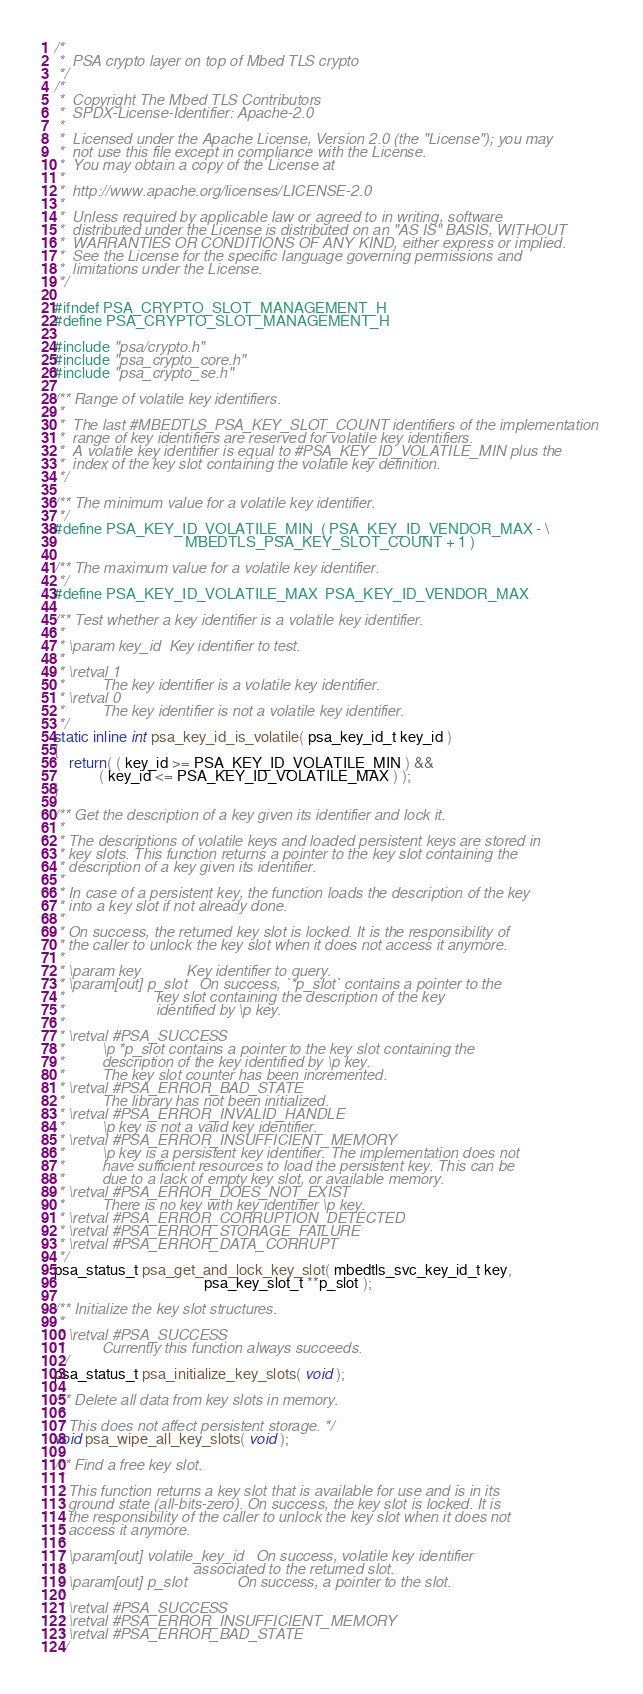Convert code to text. <code><loc_0><loc_0><loc_500><loc_500><_C_>/*
 *  PSA crypto layer on top of Mbed TLS crypto
 */
/*
 *  Copyright The Mbed TLS Contributors
 *  SPDX-License-Identifier: Apache-2.0
 *
 *  Licensed under the Apache License, Version 2.0 (the "License"); you may
 *  not use this file except in compliance with the License.
 *  You may obtain a copy of the License at
 *
 *  http://www.apache.org/licenses/LICENSE-2.0
 *
 *  Unless required by applicable law or agreed to in writing, software
 *  distributed under the License is distributed on an "AS IS" BASIS, WITHOUT
 *  WARRANTIES OR CONDITIONS OF ANY KIND, either express or implied.
 *  See the License for the specific language governing permissions and
 *  limitations under the License.
 */

#ifndef PSA_CRYPTO_SLOT_MANAGEMENT_H
#define PSA_CRYPTO_SLOT_MANAGEMENT_H

#include "psa/crypto.h"
#include "psa_crypto_core.h"
#include "psa_crypto_se.h"

/** Range of volatile key identifiers.
 *
 *  The last #MBEDTLS_PSA_KEY_SLOT_COUNT identifiers of the implementation
 *  range of key identifiers are reserved for volatile key identifiers.
 *  A volatile key identifier is equal to #PSA_KEY_ID_VOLATILE_MIN plus the
 *  index of the key slot containing the volatile key definition.
 */

/** The minimum value for a volatile key identifier.
 */
#define PSA_KEY_ID_VOLATILE_MIN  ( PSA_KEY_ID_VENDOR_MAX - \
                                   MBEDTLS_PSA_KEY_SLOT_COUNT + 1 )

/** The maximum value for a volatile key identifier.
 */
#define PSA_KEY_ID_VOLATILE_MAX  PSA_KEY_ID_VENDOR_MAX

/** Test whether a key identifier is a volatile key identifier.
 *
 * \param key_id  Key identifier to test.
 *
 * \retval 1
 *         The key identifier is a volatile key identifier.
 * \retval 0
 *         The key identifier is not a volatile key identifier.
 */
static inline int psa_key_id_is_volatile( psa_key_id_t key_id )
{
    return( ( key_id >= PSA_KEY_ID_VOLATILE_MIN ) &&
            ( key_id <= PSA_KEY_ID_VOLATILE_MAX ) );
}

/** Get the description of a key given its identifier and lock it.
 *
 * The descriptions of volatile keys and loaded persistent keys are stored in
 * key slots. This function returns a pointer to the key slot containing the
 * description of a key given its identifier.
 *
 * In case of a persistent key, the function loads the description of the key
 * into a key slot if not already done.
 *
 * On success, the returned key slot is locked. It is the responsibility of
 * the caller to unlock the key slot when it does not access it anymore.
 *
 * \param key           Key identifier to query.
 * \param[out] p_slot   On success, `*p_slot` contains a pointer to the
 *                      key slot containing the description of the key
 *                      identified by \p key.
 *
 * \retval #PSA_SUCCESS
 *         \p *p_slot contains a pointer to the key slot containing the
 *         description of the key identified by \p key.
 *         The key slot counter has been incremented.
 * \retval #PSA_ERROR_BAD_STATE
 *         The library has not been initialized.
 * \retval #PSA_ERROR_INVALID_HANDLE
 *         \p key is not a valid key identifier.
 * \retval #PSA_ERROR_INSUFFICIENT_MEMORY
 *         \p key is a persistent key identifier. The implementation does not
 *         have sufficient resources to load the persistent key. This can be
 *         due to a lack of empty key slot, or available memory.
 * \retval #PSA_ERROR_DOES_NOT_EXIST
 *         There is no key with key identifier \p key.
 * \retval #PSA_ERROR_CORRUPTION_DETECTED
 * \retval #PSA_ERROR_STORAGE_FAILURE
 * \retval #PSA_ERROR_DATA_CORRUPT
 */
psa_status_t psa_get_and_lock_key_slot( mbedtls_svc_key_id_t key,
                                        psa_key_slot_t **p_slot );

/** Initialize the key slot structures.
 *
 * \retval #PSA_SUCCESS
 *         Currently this function always succeeds.
 */
psa_status_t psa_initialize_key_slots( void );

/** Delete all data from key slots in memory.
 *
 * This does not affect persistent storage. */
void psa_wipe_all_key_slots( void );

/** Find a free key slot.
 *
 * This function returns a key slot that is available for use and is in its
 * ground state (all-bits-zero). On success, the key slot is locked. It is
 * the responsibility of the caller to unlock the key slot when it does not
 * access it anymore.
 *
 * \param[out] volatile_key_id   On success, volatile key identifier
 *                               associated to the returned slot.
 * \param[out] p_slot            On success, a pointer to the slot.
 *
 * \retval #PSA_SUCCESS
 * \retval #PSA_ERROR_INSUFFICIENT_MEMORY
 * \retval #PSA_ERROR_BAD_STATE
 */</code> 